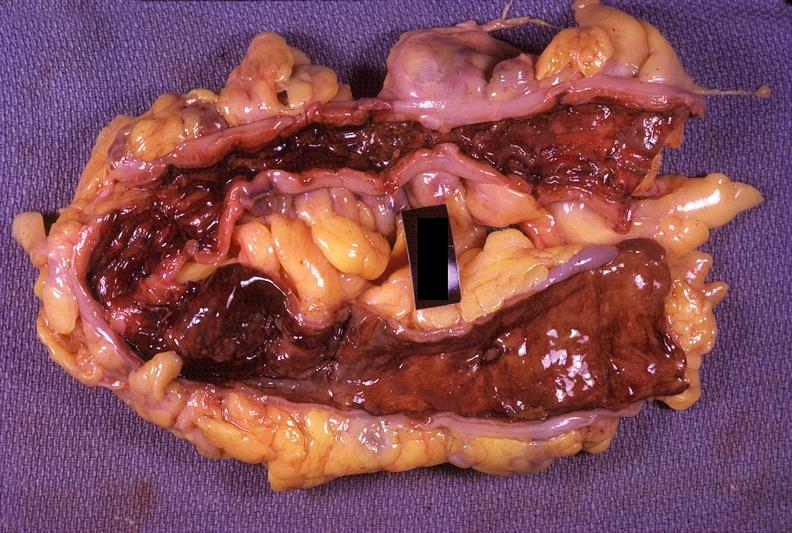what is present?
Answer the question using a single word or phrase. Gastrointestinal 